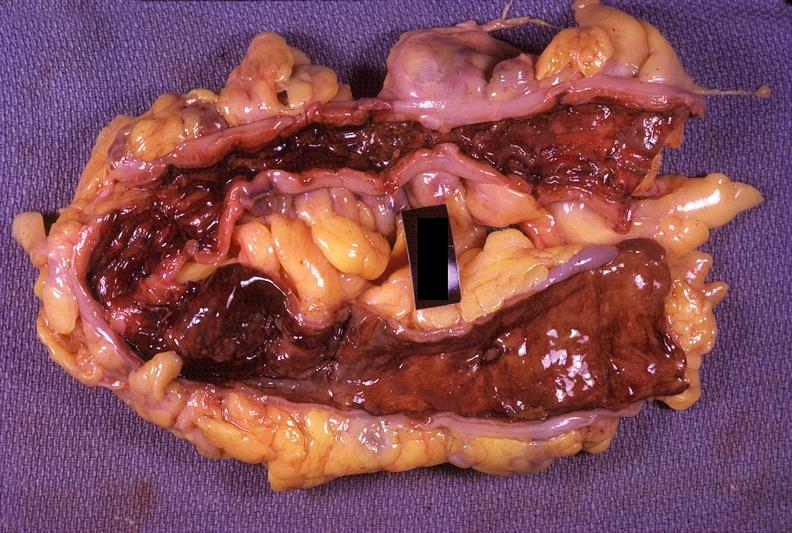what is present?
Answer the question using a single word or phrase. Gastrointestinal 